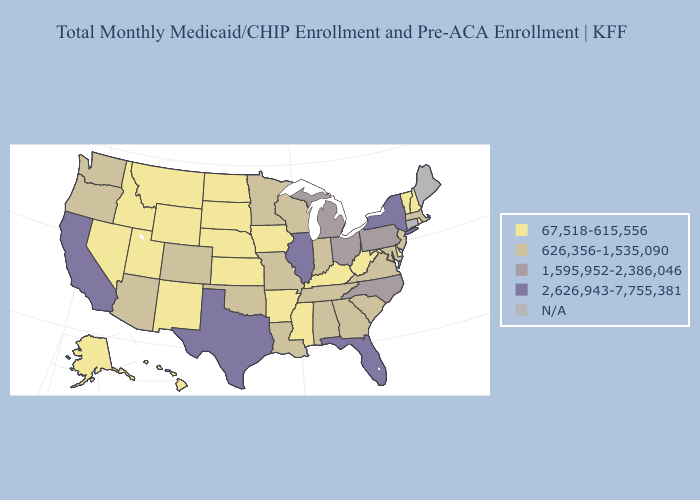What is the value of Colorado?
Concise answer only. 626,356-1,535,090. Does South Carolina have the lowest value in the USA?
Concise answer only. No. Does the first symbol in the legend represent the smallest category?
Write a very short answer. Yes. What is the value of West Virginia?
Answer briefly. 67,518-615,556. Name the states that have a value in the range N/A?
Be succinct. Connecticut, Maine. How many symbols are there in the legend?
Write a very short answer. 5. What is the lowest value in states that border Rhode Island?
Short answer required. 626,356-1,535,090. Does Colorado have the highest value in the West?
Be succinct. No. Name the states that have a value in the range 1,595,952-2,386,046?
Keep it brief. Michigan, North Carolina, Ohio, Pennsylvania. Does the first symbol in the legend represent the smallest category?
Give a very brief answer. Yes. Does California have the highest value in the USA?
Keep it brief. Yes. What is the value of Idaho?
Short answer required. 67,518-615,556. 